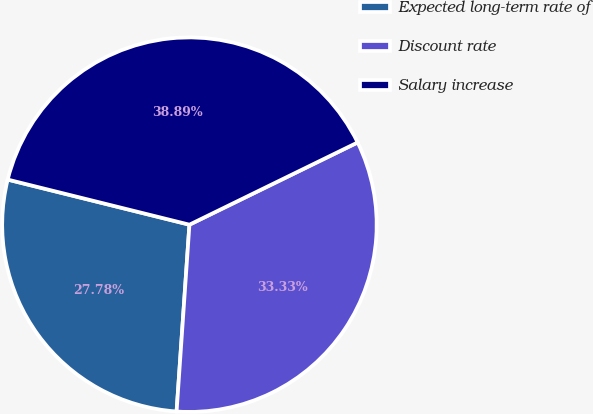Convert chart to OTSL. <chart><loc_0><loc_0><loc_500><loc_500><pie_chart><fcel>Expected long-term rate of<fcel>Discount rate<fcel>Salary increase<nl><fcel>27.78%<fcel>33.33%<fcel>38.89%<nl></chart> 